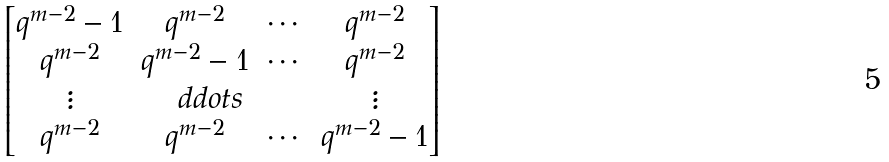Convert formula to latex. <formula><loc_0><loc_0><loc_500><loc_500>\begin{bmatrix} q ^ { m - 2 } - 1 & q ^ { m - 2 } & \cdots & q ^ { m - 2 } \\ q ^ { m - 2 } & q ^ { m - 2 } - 1 & \cdots & q ^ { m - 2 } \\ \vdots & \quad d d o t s & & \vdots \\ q ^ { m - 2 } & q ^ { m - 2 } & \cdots & q ^ { m - 2 } - 1 \end{bmatrix}</formula> 